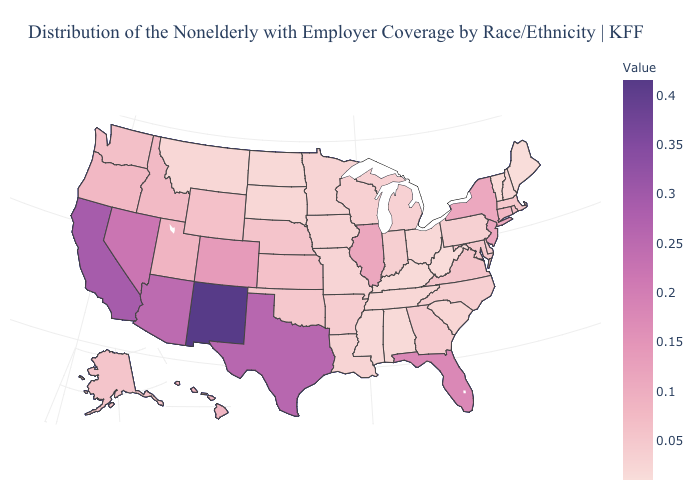Does New Mexico have the highest value in the USA?
Concise answer only. Yes. Does Maine have a higher value than Kansas?
Keep it brief. No. Among the states that border Indiana , does Illinois have the lowest value?
Be succinct. No. 